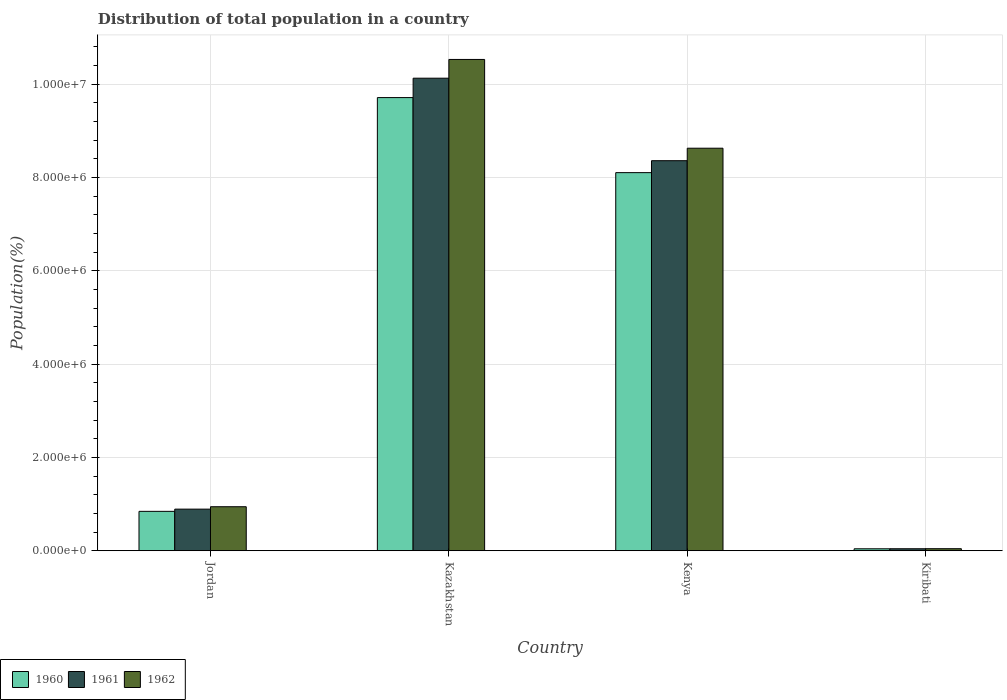How many different coloured bars are there?
Provide a short and direct response. 3. How many groups of bars are there?
Give a very brief answer. 4. Are the number of bars per tick equal to the number of legend labels?
Ensure brevity in your answer.  Yes. Are the number of bars on each tick of the X-axis equal?
Provide a succinct answer. Yes. How many bars are there on the 1st tick from the right?
Ensure brevity in your answer.  3. What is the label of the 1st group of bars from the left?
Offer a terse response. Jordan. What is the population of in 1960 in Jordan?
Offer a very short reply. 8.44e+05. Across all countries, what is the maximum population of in 1961?
Provide a succinct answer. 1.01e+07. Across all countries, what is the minimum population of in 1960?
Ensure brevity in your answer.  4.12e+04. In which country was the population of in 1962 maximum?
Provide a succinct answer. Kazakhstan. In which country was the population of in 1962 minimum?
Provide a succinct answer. Kiribati. What is the total population of in 1962 in the graph?
Give a very brief answer. 2.01e+07. What is the difference between the population of in 1961 in Jordan and that in Kiribati?
Keep it short and to the point. 8.49e+05. What is the difference between the population of in 1961 in Kiribati and the population of in 1962 in Kazakhstan?
Offer a very short reply. -1.05e+07. What is the average population of in 1961 per country?
Provide a succinct answer. 4.86e+06. What is the difference between the population of of/in 1961 and population of of/in 1960 in Jordan?
Provide a succinct answer. 4.75e+04. What is the ratio of the population of in 1962 in Jordan to that in Kazakhstan?
Provide a short and direct response. 0.09. What is the difference between the highest and the second highest population of in 1962?
Offer a terse response. -7.69e+06. What is the difference between the highest and the lowest population of in 1962?
Provide a succinct answer. 1.05e+07. In how many countries, is the population of in 1962 greater than the average population of in 1962 taken over all countries?
Your answer should be very brief. 2. How many bars are there?
Offer a terse response. 12. Are all the bars in the graph horizontal?
Offer a terse response. No. Does the graph contain grids?
Give a very brief answer. Yes. Where does the legend appear in the graph?
Give a very brief answer. Bottom left. How many legend labels are there?
Your answer should be very brief. 3. How are the legend labels stacked?
Provide a short and direct response. Horizontal. What is the title of the graph?
Your answer should be very brief. Distribution of total population in a country. Does "2015" appear as one of the legend labels in the graph?
Your answer should be compact. No. What is the label or title of the Y-axis?
Your answer should be compact. Population(%). What is the Population(%) in 1960 in Jordan?
Provide a short and direct response. 8.44e+05. What is the Population(%) of 1961 in Jordan?
Provide a succinct answer. 8.91e+05. What is the Population(%) in 1962 in Jordan?
Keep it short and to the point. 9.43e+05. What is the Population(%) in 1960 in Kazakhstan?
Your answer should be very brief. 9.71e+06. What is the Population(%) of 1961 in Kazakhstan?
Keep it short and to the point. 1.01e+07. What is the Population(%) of 1962 in Kazakhstan?
Your answer should be very brief. 1.05e+07. What is the Population(%) of 1960 in Kenya?
Give a very brief answer. 8.11e+06. What is the Population(%) in 1961 in Kenya?
Offer a terse response. 8.36e+06. What is the Population(%) of 1962 in Kenya?
Your answer should be compact. 8.63e+06. What is the Population(%) in 1960 in Kiribati?
Make the answer very short. 4.12e+04. What is the Population(%) in 1961 in Kiribati?
Give a very brief answer. 4.23e+04. What is the Population(%) in 1962 in Kiribati?
Your answer should be very brief. 4.33e+04. Across all countries, what is the maximum Population(%) in 1960?
Offer a terse response. 9.71e+06. Across all countries, what is the maximum Population(%) of 1961?
Your response must be concise. 1.01e+07. Across all countries, what is the maximum Population(%) of 1962?
Your answer should be very brief. 1.05e+07. Across all countries, what is the minimum Population(%) in 1960?
Give a very brief answer. 4.12e+04. Across all countries, what is the minimum Population(%) in 1961?
Give a very brief answer. 4.23e+04. Across all countries, what is the minimum Population(%) in 1962?
Make the answer very short. 4.33e+04. What is the total Population(%) in 1960 in the graph?
Offer a very short reply. 1.87e+07. What is the total Population(%) of 1961 in the graph?
Provide a succinct answer. 1.94e+07. What is the total Population(%) of 1962 in the graph?
Give a very brief answer. 2.01e+07. What is the difference between the Population(%) in 1960 in Jordan and that in Kazakhstan?
Your answer should be compact. -8.87e+06. What is the difference between the Population(%) of 1961 in Jordan and that in Kazakhstan?
Offer a very short reply. -9.24e+06. What is the difference between the Population(%) in 1962 in Jordan and that in Kazakhstan?
Provide a succinct answer. -9.59e+06. What is the difference between the Population(%) in 1960 in Jordan and that in Kenya?
Give a very brief answer. -7.26e+06. What is the difference between the Population(%) of 1961 in Jordan and that in Kenya?
Your answer should be compact. -7.47e+06. What is the difference between the Population(%) in 1962 in Jordan and that in Kenya?
Give a very brief answer. -7.69e+06. What is the difference between the Population(%) of 1960 in Jordan and that in Kiribati?
Your answer should be compact. 8.03e+05. What is the difference between the Population(%) of 1961 in Jordan and that in Kiribati?
Provide a succinct answer. 8.49e+05. What is the difference between the Population(%) in 1962 in Jordan and that in Kiribati?
Offer a terse response. 9.00e+05. What is the difference between the Population(%) in 1960 in Kazakhstan and that in Kenya?
Your response must be concise. 1.61e+06. What is the difference between the Population(%) of 1961 in Kazakhstan and that in Kenya?
Keep it short and to the point. 1.77e+06. What is the difference between the Population(%) of 1962 in Kazakhstan and that in Kenya?
Keep it short and to the point. 1.90e+06. What is the difference between the Population(%) of 1960 in Kazakhstan and that in Kiribati?
Provide a short and direct response. 9.67e+06. What is the difference between the Population(%) of 1961 in Kazakhstan and that in Kiribati?
Offer a very short reply. 1.01e+07. What is the difference between the Population(%) in 1962 in Kazakhstan and that in Kiribati?
Provide a short and direct response. 1.05e+07. What is the difference between the Population(%) of 1960 in Kenya and that in Kiribati?
Give a very brief answer. 8.06e+06. What is the difference between the Population(%) in 1961 in Kenya and that in Kiribati?
Ensure brevity in your answer.  8.32e+06. What is the difference between the Population(%) of 1962 in Kenya and that in Kiribati?
Your answer should be compact. 8.59e+06. What is the difference between the Population(%) in 1960 in Jordan and the Population(%) in 1961 in Kazakhstan?
Offer a very short reply. -9.29e+06. What is the difference between the Population(%) of 1960 in Jordan and the Population(%) of 1962 in Kazakhstan?
Give a very brief answer. -9.69e+06. What is the difference between the Population(%) in 1961 in Jordan and the Population(%) in 1962 in Kazakhstan?
Your response must be concise. -9.64e+06. What is the difference between the Population(%) of 1960 in Jordan and the Population(%) of 1961 in Kenya?
Your answer should be very brief. -7.52e+06. What is the difference between the Population(%) in 1960 in Jordan and the Population(%) in 1962 in Kenya?
Offer a terse response. -7.78e+06. What is the difference between the Population(%) of 1961 in Jordan and the Population(%) of 1962 in Kenya?
Your answer should be very brief. -7.74e+06. What is the difference between the Population(%) in 1960 in Jordan and the Population(%) in 1961 in Kiribati?
Your response must be concise. 8.02e+05. What is the difference between the Population(%) in 1960 in Jordan and the Population(%) in 1962 in Kiribati?
Offer a terse response. 8.01e+05. What is the difference between the Population(%) in 1961 in Jordan and the Population(%) in 1962 in Kiribati?
Keep it short and to the point. 8.48e+05. What is the difference between the Population(%) of 1960 in Kazakhstan and the Population(%) of 1961 in Kenya?
Ensure brevity in your answer.  1.35e+06. What is the difference between the Population(%) of 1960 in Kazakhstan and the Population(%) of 1962 in Kenya?
Make the answer very short. 1.09e+06. What is the difference between the Population(%) of 1961 in Kazakhstan and the Population(%) of 1962 in Kenya?
Your answer should be compact. 1.50e+06. What is the difference between the Population(%) of 1960 in Kazakhstan and the Population(%) of 1961 in Kiribati?
Offer a very short reply. 9.67e+06. What is the difference between the Population(%) of 1960 in Kazakhstan and the Population(%) of 1962 in Kiribati?
Your answer should be very brief. 9.67e+06. What is the difference between the Population(%) of 1961 in Kazakhstan and the Population(%) of 1962 in Kiribati?
Give a very brief answer. 1.01e+07. What is the difference between the Population(%) in 1960 in Kenya and the Population(%) in 1961 in Kiribati?
Your answer should be compact. 8.06e+06. What is the difference between the Population(%) of 1960 in Kenya and the Population(%) of 1962 in Kiribati?
Offer a very short reply. 8.06e+06. What is the difference between the Population(%) in 1961 in Kenya and the Population(%) in 1962 in Kiribati?
Your response must be concise. 8.32e+06. What is the average Population(%) of 1960 per country?
Ensure brevity in your answer.  4.68e+06. What is the average Population(%) in 1961 per country?
Your response must be concise. 4.86e+06. What is the average Population(%) of 1962 per country?
Ensure brevity in your answer.  5.04e+06. What is the difference between the Population(%) in 1960 and Population(%) in 1961 in Jordan?
Ensure brevity in your answer.  -4.75e+04. What is the difference between the Population(%) in 1960 and Population(%) in 1962 in Jordan?
Ensure brevity in your answer.  -9.91e+04. What is the difference between the Population(%) in 1961 and Population(%) in 1962 in Jordan?
Ensure brevity in your answer.  -5.16e+04. What is the difference between the Population(%) of 1960 and Population(%) of 1961 in Kazakhstan?
Provide a succinct answer. -4.16e+05. What is the difference between the Population(%) of 1960 and Population(%) of 1962 in Kazakhstan?
Your answer should be very brief. -8.18e+05. What is the difference between the Population(%) of 1961 and Population(%) of 1962 in Kazakhstan?
Your response must be concise. -4.02e+05. What is the difference between the Population(%) of 1960 and Population(%) of 1961 in Kenya?
Your answer should be compact. -2.56e+05. What is the difference between the Population(%) in 1960 and Population(%) in 1962 in Kenya?
Keep it short and to the point. -5.24e+05. What is the difference between the Population(%) in 1961 and Population(%) in 1962 in Kenya?
Ensure brevity in your answer.  -2.68e+05. What is the difference between the Population(%) in 1960 and Population(%) in 1961 in Kiribati?
Make the answer very short. -1027. What is the difference between the Population(%) of 1960 and Population(%) of 1962 in Kiribati?
Your answer should be compact. -2078. What is the difference between the Population(%) in 1961 and Population(%) in 1962 in Kiribati?
Your response must be concise. -1051. What is the ratio of the Population(%) in 1960 in Jordan to that in Kazakhstan?
Provide a succinct answer. 0.09. What is the ratio of the Population(%) of 1961 in Jordan to that in Kazakhstan?
Your answer should be compact. 0.09. What is the ratio of the Population(%) in 1962 in Jordan to that in Kazakhstan?
Ensure brevity in your answer.  0.09. What is the ratio of the Population(%) in 1960 in Jordan to that in Kenya?
Your answer should be compact. 0.1. What is the ratio of the Population(%) in 1961 in Jordan to that in Kenya?
Your answer should be compact. 0.11. What is the ratio of the Population(%) in 1962 in Jordan to that in Kenya?
Provide a short and direct response. 0.11. What is the ratio of the Population(%) in 1960 in Jordan to that in Kiribati?
Provide a short and direct response. 20.47. What is the ratio of the Population(%) in 1961 in Jordan to that in Kiribati?
Your response must be concise. 21.09. What is the ratio of the Population(%) in 1962 in Jordan to that in Kiribati?
Ensure brevity in your answer.  21.77. What is the ratio of the Population(%) in 1960 in Kazakhstan to that in Kenya?
Your answer should be compact. 1.2. What is the ratio of the Population(%) of 1961 in Kazakhstan to that in Kenya?
Give a very brief answer. 1.21. What is the ratio of the Population(%) in 1962 in Kazakhstan to that in Kenya?
Provide a succinct answer. 1.22. What is the ratio of the Population(%) in 1960 in Kazakhstan to that in Kiribati?
Your answer should be very brief. 235.59. What is the ratio of the Population(%) of 1961 in Kazakhstan to that in Kiribati?
Offer a very short reply. 239.7. What is the ratio of the Population(%) in 1962 in Kazakhstan to that in Kiribati?
Make the answer very short. 243.17. What is the ratio of the Population(%) in 1960 in Kenya to that in Kiribati?
Offer a terse response. 196.57. What is the ratio of the Population(%) in 1961 in Kenya to that in Kiribati?
Offer a very short reply. 197.85. What is the ratio of the Population(%) in 1962 in Kenya to that in Kiribati?
Provide a short and direct response. 199.23. What is the difference between the highest and the second highest Population(%) in 1960?
Your answer should be compact. 1.61e+06. What is the difference between the highest and the second highest Population(%) of 1961?
Ensure brevity in your answer.  1.77e+06. What is the difference between the highest and the second highest Population(%) of 1962?
Provide a short and direct response. 1.90e+06. What is the difference between the highest and the lowest Population(%) of 1960?
Offer a very short reply. 9.67e+06. What is the difference between the highest and the lowest Population(%) of 1961?
Provide a succinct answer. 1.01e+07. What is the difference between the highest and the lowest Population(%) of 1962?
Your answer should be compact. 1.05e+07. 